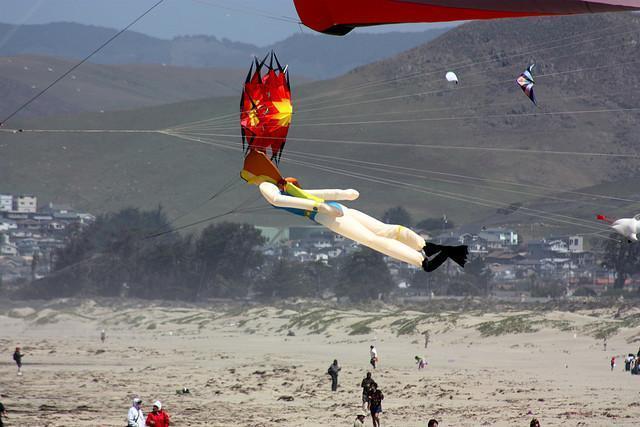How many kites are there?
Give a very brief answer. 3. How many dogs are there?
Give a very brief answer. 0. 